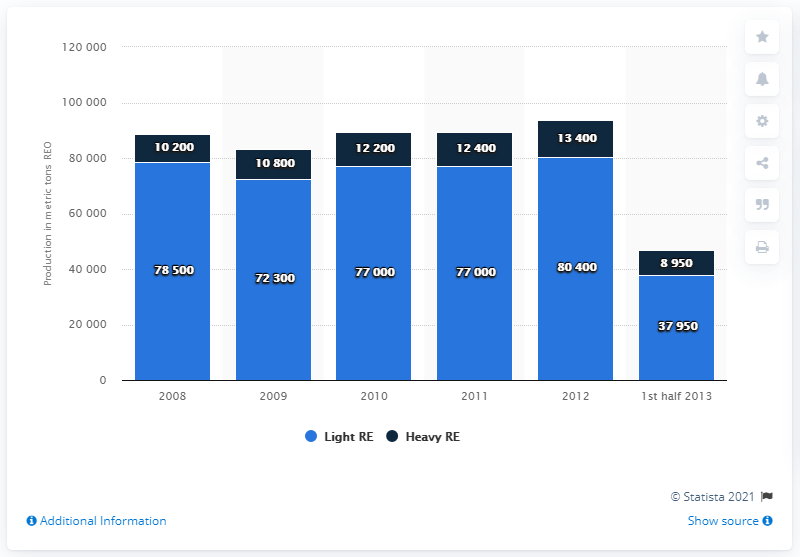Outline some significant characteristics in this image. The production of light reached its peak in 2012. In 2010, China produced approximately 77,000 metric tons of light rare earths. In 2011, the production of both light and heavy crude oil was reported to be 64,600 barrels per day. 